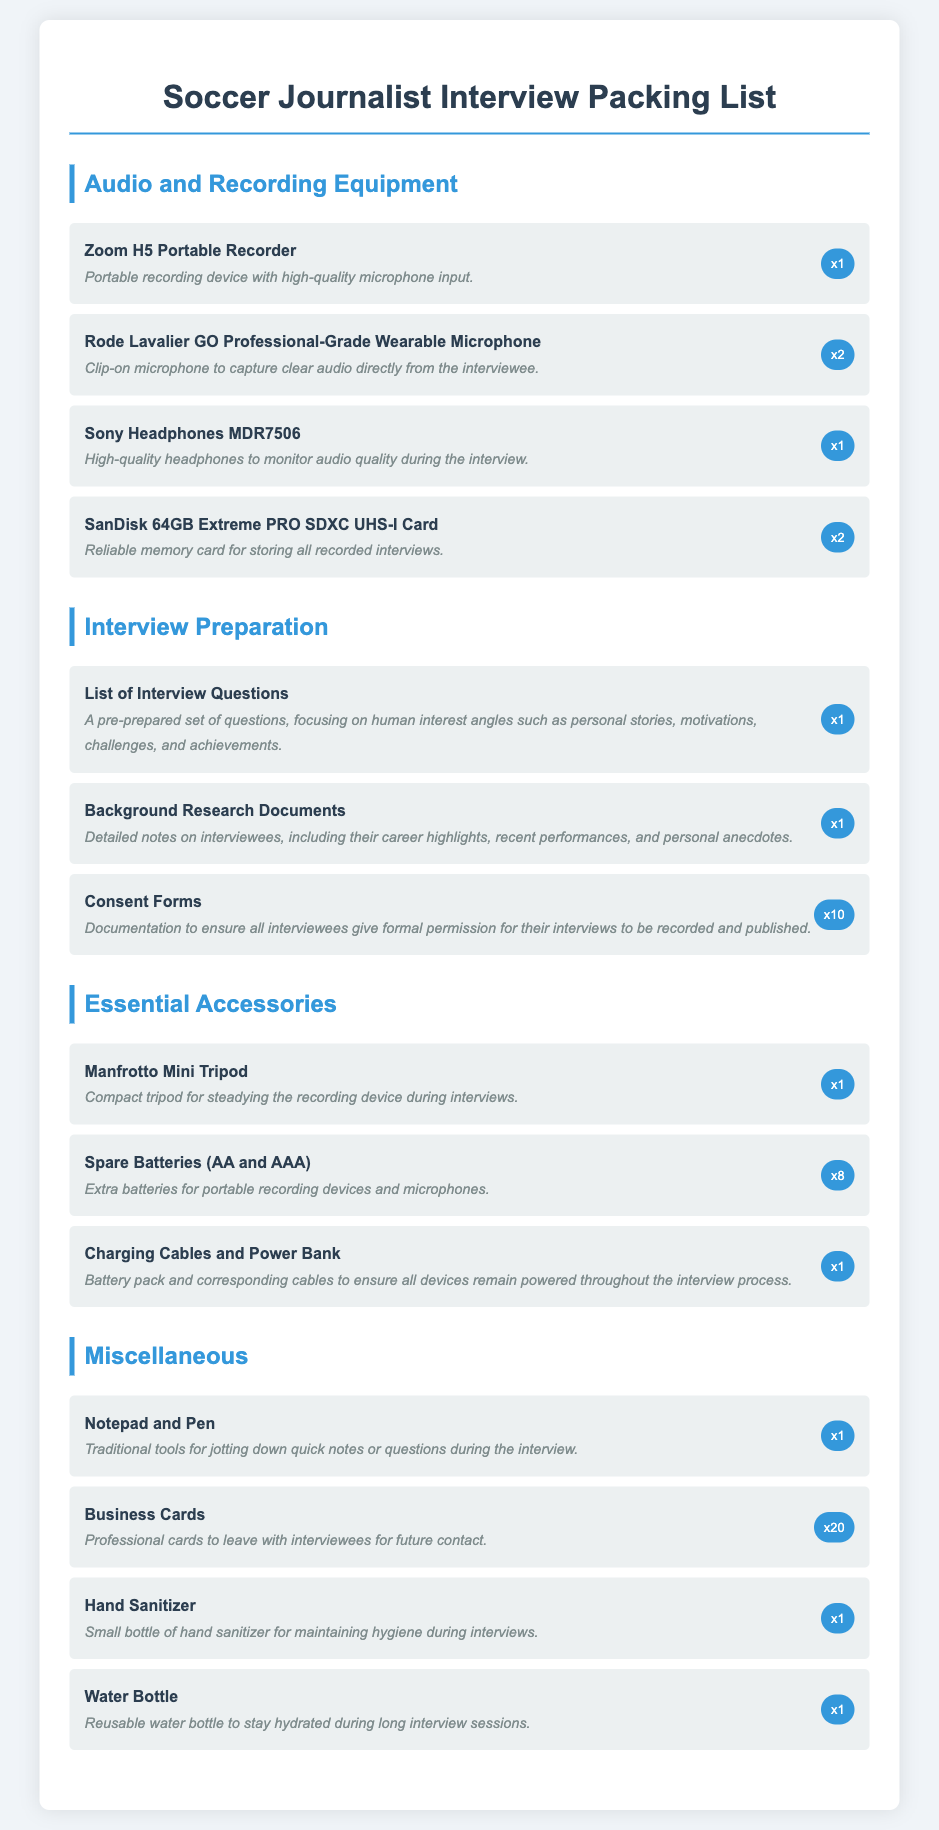what is the name of the portable recording device? The document lists the "Zoom H5 Portable Recorder" as the portable recording device required for interviews.
Answer: Zoom H5 Portable Recorder how many consent forms are included in the packing list? The packing list specifies that 10 consent forms are needed for the interviews.
Answer: x10 what type of microphone is the Rode Lavalier GO? The document describes the Rode Lavalier GO as a "Professional-Grade Wearable Microphone."
Answer: Professional-Grade Wearable Microphone what is the purpose of the SanDisk 64GB Extreme PRO SDXC UHS-I Card? The packing list indicates that the card is for storing all recorded interviews.
Answer: Storing all recorded interviews which accessory is listed for ensuring hygiene during interviews? The document lists "Hand Sanitizer" as an accessory for maintaining hygiene.
Answer: Hand Sanitizer how many spare batteries are recommended in the packing list? The packing list recommends having 8 spare batteries, both AA and AAA types.
Answer: x8 what item is described as traditional tools for jotting down notes? The document mentions "Notepad and Pen" as traditional tools for taking notes during interviews.
Answer: Notepad and Pen what is the suggested number of business cards to carry? The packing list suggests carrying 20 business cards for professional networking.
Answer: x20 